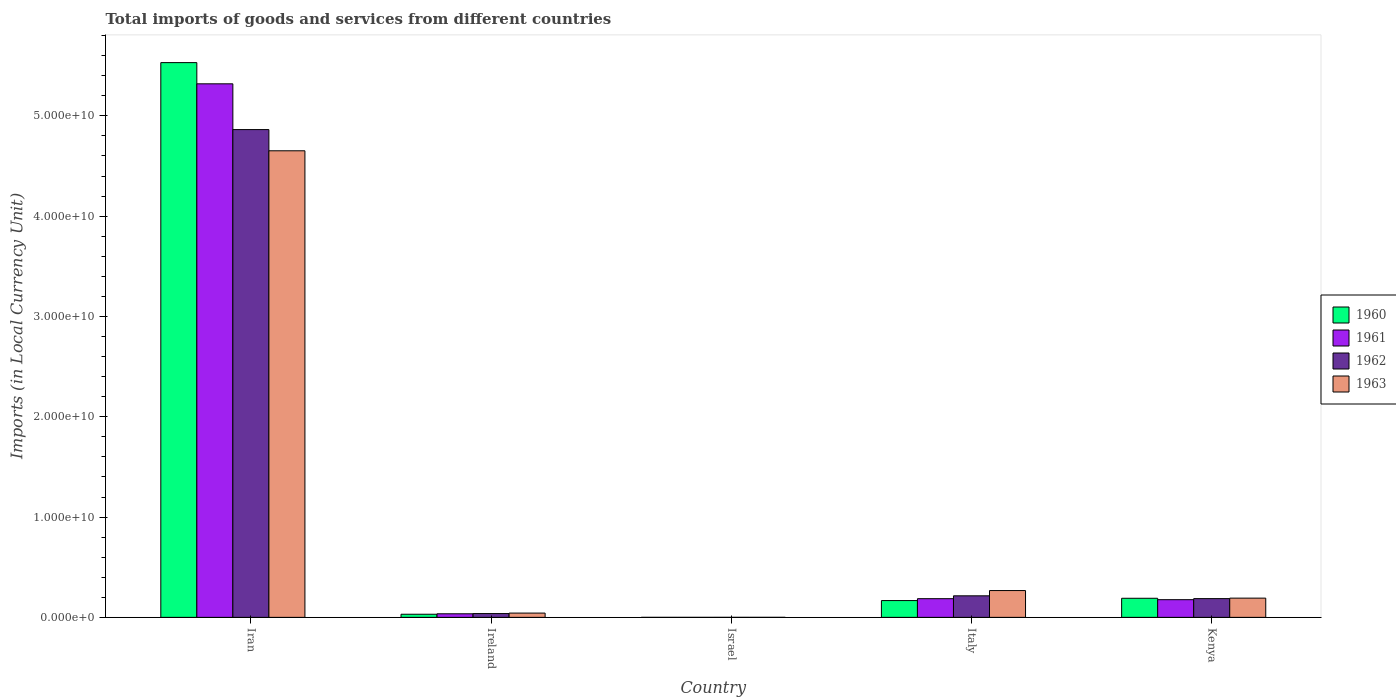What is the label of the 2nd group of bars from the left?
Keep it short and to the point. Ireland. What is the Amount of goods and services imports in 1962 in Iran?
Your answer should be compact. 4.86e+1. Across all countries, what is the maximum Amount of goods and services imports in 1960?
Your answer should be very brief. 5.53e+1. Across all countries, what is the minimum Amount of goods and services imports in 1962?
Offer a very short reply. 1.26e+05. In which country was the Amount of goods and services imports in 1962 maximum?
Provide a succinct answer. Iran. What is the total Amount of goods and services imports in 1961 in the graph?
Your response must be concise. 5.72e+1. What is the difference between the Amount of goods and services imports in 1960 in Ireland and that in Italy?
Your answer should be compact. -1.36e+09. What is the difference between the Amount of goods and services imports in 1961 in Iran and the Amount of goods and services imports in 1960 in Israel?
Keep it short and to the point. 5.32e+1. What is the average Amount of goods and services imports in 1960 per country?
Your answer should be compact. 1.18e+1. What is the difference between the Amount of goods and services imports of/in 1963 and Amount of goods and services imports of/in 1961 in Italy?
Offer a terse response. 8.10e+08. In how many countries, is the Amount of goods and services imports in 1961 greater than 26000000000 LCU?
Make the answer very short. 1. What is the ratio of the Amount of goods and services imports in 1961 in Iran to that in Israel?
Make the answer very short. 7.56e+05. Is the Amount of goods and services imports in 1961 in Ireland less than that in Italy?
Keep it short and to the point. Yes. Is the difference between the Amount of goods and services imports in 1963 in Italy and Kenya greater than the difference between the Amount of goods and services imports in 1961 in Italy and Kenya?
Your answer should be very brief. Yes. What is the difference between the highest and the second highest Amount of goods and services imports in 1960?
Give a very brief answer. -2.29e+08. What is the difference between the highest and the lowest Amount of goods and services imports in 1961?
Your answer should be compact. 5.32e+1. In how many countries, is the Amount of goods and services imports in 1960 greater than the average Amount of goods and services imports in 1960 taken over all countries?
Give a very brief answer. 1. Is it the case that in every country, the sum of the Amount of goods and services imports in 1960 and Amount of goods and services imports in 1962 is greater than the sum of Amount of goods and services imports in 1961 and Amount of goods and services imports in 1963?
Make the answer very short. No. What does the 4th bar from the left in Israel represents?
Offer a very short reply. 1963. Is it the case that in every country, the sum of the Amount of goods and services imports in 1960 and Amount of goods and services imports in 1961 is greater than the Amount of goods and services imports in 1962?
Offer a very short reply. Yes. How many countries are there in the graph?
Your answer should be very brief. 5. What is the difference between two consecutive major ticks on the Y-axis?
Your answer should be very brief. 1.00e+1. Does the graph contain grids?
Keep it short and to the point. No. Where does the legend appear in the graph?
Your answer should be very brief. Center right. How are the legend labels stacked?
Your answer should be very brief. Vertical. What is the title of the graph?
Make the answer very short. Total imports of goods and services from different countries. What is the label or title of the X-axis?
Provide a succinct answer. Country. What is the label or title of the Y-axis?
Offer a terse response. Imports (in Local Currency Unit). What is the Imports (in Local Currency Unit) of 1960 in Iran?
Ensure brevity in your answer.  5.53e+1. What is the Imports (in Local Currency Unit) of 1961 in Iran?
Provide a short and direct response. 5.32e+1. What is the Imports (in Local Currency Unit) in 1962 in Iran?
Your response must be concise. 4.86e+1. What is the Imports (in Local Currency Unit) of 1963 in Iran?
Your answer should be very brief. 4.65e+1. What is the Imports (in Local Currency Unit) of 1960 in Ireland?
Keep it short and to the point. 3.10e+08. What is the Imports (in Local Currency Unit) in 1961 in Ireland?
Offer a terse response. 3.57e+08. What is the Imports (in Local Currency Unit) of 1962 in Ireland?
Offer a terse response. 3.78e+08. What is the Imports (in Local Currency Unit) of 1963 in Ireland?
Give a very brief answer. 4.26e+08. What is the Imports (in Local Currency Unit) in 1960 in Israel?
Offer a very short reply. 5.78e+04. What is the Imports (in Local Currency Unit) of 1961 in Israel?
Provide a short and direct response. 7.04e+04. What is the Imports (in Local Currency Unit) in 1962 in Israel?
Ensure brevity in your answer.  1.26e+05. What is the Imports (in Local Currency Unit) of 1963 in Israel?
Offer a terse response. 1.44e+05. What is the Imports (in Local Currency Unit) in 1960 in Italy?
Make the answer very short. 1.67e+09. What is the Imports (in Local Currency Unit) of 1961 in Italy?
Your answer should be compact. 1.86e+09. What is the Imports (in Local Currency Unit) in 1962 in Italy?
Ensure brevity in your answer.  2.15e+09. What is the Imports (in Local Currency Unit) in 1963 in Italy?
Offer a terse response. 2.67e+09. What is the Imports (in Local Currency Unit) of 1960 in Kenya?
Ensure brevity in your answer.  1.90e+09. What is the Imports (in Local Currency Unit) in 1961 in Kenya?
Ensure brevity in your answer.  1.76e+09. What is the Imports (in Local Currency Unit) in 1962 in Kenya?
Offer a very short reply. 1.87e+09. What is the Imports (in Local Currency Unit) in 1963 in Kenya?
Make the answer very short. 1.92e+09. Across all countries, what is the maximum Imports (in Local Currency Unit) in 1960?
Your response must be concise. 5.53e+1. Across all countries, what is the maximum Imports (in Local Currency Unit) of 1961?
Keep it short and to the point. 5.32e+1. Across all countries, what is the maximum Imports (in Local Currency Unit) in 1962?
Your answer should be compact. 4.86e+1. Across all countries, what is the maximum Imports (in Local Currency Unit) in 1963?
Offer a terse response. 4.65e+1. Across all countries, what is the minimum Imports (in Local Currency Unit) of 1960?
Keep it short and to the point. 5.78e+04. Across all countries, what is the minimum Imports (in Local Currency Unit) of 1961?
Ensure brevity in your answer.  7.04e+04. Across all countries, what is the minimum Imports (in Local Currency Unit) of 1962?
Give a very brief answer. 1.26e+05. Across all countries, what is the minimum Imports (in Local Currency Unit) in 1963?
Provide a succinct answer. 1.44e+05. What is the total Imports (in Local Currency Unit) in 1960 in the graph?
Provide a succinct answer. 5.92e+1. What is the total Imports (in Local Currency Unit) in 1961 in the graph?
Keep it short and to the point. 5.72e+1. What is the total Imports (in Local Currency Unit) in 1962 in the graph?
Your answer should be very brief. 5.30e+1. What is the total Imports (in Local Currency Unit) of 1963 in the graph?
Give a very brief answer. 5.15e+1. What is the difference between the Imports (in Local Currency Unit) of 1960 in Iran and that in Ireland?
Your answer should be compact. 5.50e+1. What is the difference between the Imports (in Local Currency Unit) of 1961 in Iran and that in Ireland?
Offer a terse response. 5.28e+1. What is the difference between the Imports (in Local Currency Unit) in 1962 in Iran and that in Ireland?
Provide a succinct answer. 4.83e+1. What is the difference between the Imports (in Local Currency Unit) of 1963 in Iran and that in Ireland?
Make the answer very short. 4.61e+1. What is the difference between the Imports (in Local Currency Unit) in 1960 in Iran and that in Israel?
Offer a terse response. 5.53e+1. What is the difference between the Imports (in Local Currency Unit) in 1961 in Iran and that in Israel?
Make the answer very short. 5.32e+1. What is the difference between the Imports (in Local Currency Unit) in 1962 in Iran and that in Israel?
Ensure brevity in your answer.  4.86e+1. What is the difference between the Imports (in Local Currency Unit) in 1963 in Iran and that in Israel?
Provide a short and direct response. 4.65e+1. What is the difference between the Imports (in Local Currency Unit) of 1960 in Iran and that in Italy?
Ensure brevity in your answer.  5.36e+1. What is the difference between the Imports (in Local Currency Unit) in 1961 in Iran and that in Italy?
Give a very brief answer. 5.13e+1. What is the difference between the Imports (in Local Currency Unit) of 1962 in Iran and that in Italy?
Offer a very short reply. 4.65e+1. What is the difference between the Imports (in Local Currency Unit) in 1963 in Iran and that in Italy?
Make the answer very short. 4.38e+1. What is the difference between the Imports (in Local Currency Unit) of 1960 in Iran and that in Kenya?
Provide a succinct answer. 5.34e+1. What is the difference between the Imports (in Local Currency Unit) in 1961 in Iran and that in Kenya?
Provide a short and direct response. 5.14e+1. What is the difference between the Imports (in Local Currency Unit) in 1962 in Iran and that in Kenya?
Provide a short and direct response. 4.68e+1. What is the difference between the Imports (in Local Currency Unit) of 1963 in Iran and that in Kenya?
Your answer should be compact. 4.46e+1. What is the difference between the Imports (in Local Currency Unit) in 1960 in Ireland and that in Israel?
Your answer should be compact. 3.10e+08. What is the difference between the Imports (in Local Currency Unit) of 1961 in Ireland and that in Israel?
Give a very brief answer. 3.56e+08. What is the difference between the Imports (in Local Currency Unit) of 1962 in Ireland and that in Israel?
Ensure brevity in your answer.  3.77e+08. What is the difference between the Imports (in Local Currency Unit) of 1963 in Ireland and that in Israel?
Offer a terse response. 4.25e+08. What is the difference between the Imports (in Local Currency Unit) of 1960 in Ireland and that in Italy?
Provide a short and direct response. -1.36e+09. What is the difference between the Imports (in Local Currency Unit) of 1961 in Ireland and that in Italy?
Provide a short and direct response. -1.51e+09. What is the difference between the Imports (in Local Currency Unit) in 1962 in Ireland and that in Italy?
Make the answer very short. -1.77e+09. What is the difference between the Imports (in Local Currency Unit) of 1963 in Ireland and that in Italy?
Give a very brief answer. -2.25e+09. What is the difference between the Imports (in Local Currency Unit) in 1960 in Ireland and that in Kenya?
Your response must be concise. -1.59e+09. What is the difference between the Imports (in Local Currency Unit) of 1961 in Ireland and that in Kenya?
Keep it short and to the point. -1.41e+09. What is the difference between the Imports (in Local Currency Unit) in 1962 in Ireland and that in Kenya?
Provide a short and direct response. -1.49e+09. What is the difference between the Imports (in Local Currency Unit) in 1963 in Ireland and that in Kenya?
Your response must be concise. -1.49e+09. What is the difference between the Imports (in Local Currency Unit) of 1960 in Israel and that in Italy?
Provide a short and direct response. -1.67e+09. What is the difference between the Imports (in Local Currency Unit) in 1961 in Israel and that in Italy?
Your answer should be very brief. -1.86e+09. What is the difference between the Imports (in Local Currency Unit) in 1962 in Israel and that in Italy?
Offer a terse response. -2.15e+09. What is the difference between the Imports (in Local Currency Unit) of 1963 in Israel and that in Italy?
Keep it short and to the point. -2.67e+09. What is the difference between the Imports (in Local Currency Unit) in 1960 in Israel and that in Kenya?
Provide a succinct answer. -1.90e+09. What is the difference between the Imports (in Local Currency Unit) in 1961 in Israel and that in Kenya?
Ensure brevity in your answer.  -1.76e+09. What is the difference between the Imports (in Local Currency Unit) of 1962 in Israel and that in Kenya?
Ensure brevity in your answer.  -1.87e+09. What is the difference between the Imports (in Local Currency Unit) of 1963 in Israel and that in Kenya?
Offer a very short reply. -1.92e+09. What is the difference between the Imports (in Local Currency Unit) in 1960 in Italy and that in Kenya?
Give a very brief answer. -2.29e+08. What is the difference between the Imports (in Local Currency Unit) in 1961 in Italy and that in Kenya?
Keep it short and to the point. 9.87e+07. What is the difference between the Imports (in Local Currency Unit) of 1962 in Italy and that in Kenya?
Offer a very short reply. 2.80e+08. What is the difference between the Imports (in Local Currency Unit) in 1963 in Italy and that in Kenya?
Offer a terse response. 7.55e+08. What is the difference between the Imports (in Local Currency Unit) in 1960 in Iran and the Imports (in Local Currency Unit) in 1961 in Ireland?
Make the answer very short. 5.50e+1. What is the difference between the Imports (in Local Currency Unit) in 1960 in Iran and the Imports (in Local Currency Unit) in 1962 in Ireland?
Your response must be concise. 5.49e+1. What is the difference between the Imports (in Local Currency Unit) in 1960 in Iran and the Imports (in Local Currency Unit) in 1963 in Ireland?
Provide a short and direct response. 5.49e+1. What is the difference between the Imports (in Local Currency Unit) in 1961 in Iran and the Imports (in Local Currency Unit) in 1962 in Ireland?
Provide a short and direct response. 5.28e+1. What is the difference between the Imports (in Local Currency Unit) of 1961 in Iran and the Imports (in Local Currency Unit) of 1963 in Ireland?
Give a very brief answer. 5.28e+1. What is the difference between the Imports (in Local Currency Unit) in 1962 in Iran and the Imports (in Local Currency Unit) in 1963 in Ireland?
Provide a short and direct response. 4.82e+1. What is the difference between the Imports (in Local Currency Unit) of 1960 in Iran and the Imports (in Local Currency Unit) of 1961 in Israel?
Offer a very short reply. 5.53e+1. What is the difference between the Imports (in Local Currency Unit) of 1960 in Iran and the Imports (in Local Currency Unit) of 1962 in Israel?
Offer a very short reply. 5.53e+1. What is the difference between the Imports (in Local Currency Unit) of 1960 in Iran and the Imports (in Local Currency Unit) of 1963 in Israel?
Offer a very short reply. 5.53e+1. What is the difference between the Imports (in Local Currency Unit) of 1961 in Iran and the Imports (in Local Currency Unit) of 1962 in Israel?
Give a very brief answer. 5.32e+1. What is the difference between the Imports (in Local Currency Unit) of 1961 in Iran and the Imports (in Local Currency Unit) of 1963 in Israel?
Ensure brevity in your answer.  5.32e+1. What is the difference between the Imports (in Local Currency Unit) in 1962 in Iran and the Imports (in Local Currency Unit) in 1963 in Israel?
Keep it short and to the point. 4.86e+1. What is the difference between the Imports (in Local Currency Unit) in 1960 in Iran and the Imports (in Local Currency Unit) in 1961 in Italy?
Provide a succinct answer. 5.34e+1. What is the difference between the Imports (in Local Currency Unit) in 1960 in Iran and the Imports (in Local Currency Unit) in 1962 in Italy?
Provide a short and direct response. 5.32e+1. What is the difference between the Imports (in Local Currency Unit) of 1960 in Iran and the Imports (in Local Currency Unit) of 1963 in Italy?
Keep it short and to the point. 5.26e+1. What is the difference between the Imports (in Local Currency Unit) in 1961 in Iran and the Imports (in Local Currency Unit) in 1962 in Italy?
Offer a terse response. 5.10e+1. What is the difference between the Imports (in Local Currency Unit) of 1961 in Iran and the Imports (in Local Currency Unit) of 1963 in Italy?
Give a very brief answer. 5.05e+1. What is the difference between the Imports (in Local Currency Unit) of 1962 in Iran and the Imports (in Local Currency Unit) of 1963 in Italy?
Give a very brief answer. 4.60e+1. What is the difference between the Imports (in Local Currency Unit) of 1960 in Iran and the Imports (in Local Currency Unit) of 1961 in Kenya?
Offer a terse response. 5.35e+1. What is the difference between the Imports (in Local Currency Unit) of 1960 in Iran and the Imports (in Local Currency Unit) of 1962 in Kenya?
Your response must be concise. 5.34e+1. What is the difference between the Imports (in Local Currency Unit) of 1960 in Iran and the Imports (in Local Currency Unit) of 1963 in Kenya?
Your answer should be very brief. 5.34e+1. What is the difference between the Imports (in Local Currency Unit) of 1961 in Iran and the Imports (in Local Currency Unit) of 1962 in Kenya?
Give a very brief answer. 5.13e+1. What is the difference between the Imports (in Local Currency Unit) in 1961 in Iran and the Imports (in Local Currency Unit) in 1963 in Kenya?
Your answer should be compact. 5.13e+1. What is the difference between the Imports (in Local Currency Unit) in 1962 in Iran and the Imports (in Local Currency Unit) in 1963 in Kenya?
Keep it short and to the point. 4.67e+1. What is the difference between the Imports (in Local Currency Unit) of 1960 in Ireland and the Imports (in Local Currency Unit) of 1961 in Israel?
Make the answer very short. 3.10e+08. What is the difference between the Imports (in Local Currency Unit) in 1960 in Ireland and the Imports (in Local Currency Unit) in 1962 in Israel?
Your response must be concise. 3.10e+08. What is the difference between the Imports (in Local Currency Unit) in 1960 in Ireland and the Imports (in Local Currency Unit) in 1963 in Israel?
Give a very brief answer. 3.10e+08. What is the difference between the Imports (in Local Currency Unit) in 1961 in Ireland and the Imports (in Local Currency Unit) in 1962 in Israel?
Your answer should be very brief. 3.56e+08. What is the difference between the Imports (in Local Currency Unit) of 1961 in Ireland and the Imports (in Local Currency Unit) of 1963 in Israel?
Provide a short and direct response. 3.56e+08. What is the difference between the Imports (in Local Currency Unit) in 1962 in Ireland and the Imports (in Local Currency Unit) in 1963 in Israel?
Give a very brief answer. 3.77e+08. What is the difference between the Imports (in Local Currency Unit) of 1960 in Ireland and the Imports (in Local Currency Unit) of 1961 in Italy?
Your answer should be compact. -1.55e+09. What is the difference between the Imports (in Local Currency Unit) in 1960 in Ireland and the Imports (in Local Currency Unit) in 1962 in Italy?
Offer a terse response. -1.84e+09. What is the difference between the Imports (in Local Currency Unit) in 1960 in Ireland and the Imports (in Local Currency Unit) in 1963 in Italy?
Provide a short and direct response. -2.36e+09. What is the difference between the Imports (in Local Currency Unit) in 1961 in Ireland and the Imports (in Local Currency Unit) in 1962 in Italy?
Your answer should be very brief. -1.79e+09. What is the difference between the Imports (in Local Currency Unit) of 1961 in Ireland and the Imports (in Local Currency Unit) of 1963 in Italy?
Offer a very short reply. -2.32e+09. What is the difference between the Imports (in Local Currency Unit) of 1962 in Ireland and the Imports (in Local Currency Unit) of 1963 in Italy?
Provide a short and direct response. -2.29e+09. What is the difference between the Imports (in Local Currency Unit) in 1960 in Ireland and the Imports (in Local Currency Unit) in 1961 in Kenya?
Offer a very short reply. -1.45e+09. What is the difference between the Imports (in Local Currency Unit) of 1960 in Ireland and the Imports (in Local Currency Unit) of 1962 in Kenya?
Your answer should be very brief. -1.56e+09. What is the difference between the Imports (in Local Currency Unit) of 1960 in Ireland and the Imports (in Local Currency Unit) of 1963 in Kenya?
Offer a terse response. -1.61e+09. What is the difference between the Imports (in Local Currency Unit) of 1961 in Ireland and the Imports (in Local Currency Unit) of 1962 in Kenya?
Offer a terse response. -1.51e+09. What is the difference between the Imports (in Local Currency Unit) in 1961 in Ireland and the Imports (in Local Currency Unit) in 1963 in Kenya?
Keep it short and to the point. -1.56e+09. What is the difference between the Imports (in Local Currency Unit) of 1962 in Ireland and the Imports (in Local Currency Unit) of 1963 in Kenya?
Make the answer very short. -1.54e+09. What is the difference between the Imports (in Local Currency Unit) in 1960 in Israel and the Imports (in Local Currency Unit) in 1961 in Italy?
Provide a short and direct response. -1.86e+09. What is the difference between the Imports (in Local Currency Unit) of 1960 in Israel and the Imports (in Local Currency Unit) of 1962 in Italy?
Your answer should be compact. -2.15e+09. What is the difference between the Imports (in Local Currency Unit) in 1960 in Israel and the Imports (in Local Currency Unit) in 1963 in Italy?
Offer a very short reply. -2.67e+09. What is the difference between the Imports (in Local Currency Unit) of 1961 in Israel and the Imports (in Local Currency Unit) of 1962 in Italy?
Offer a very short reply. -2.15e+09. What is the difference between the Imports (in Local Currency Unit) in 1961 in Israel and the Imports (in Local Currency Unit) in 1963 in Italy?
Your answer should be compact. -2.67e+09. What is the difference between the Imports (in Local Currency Unit) in 1962 in Israel and the Imports (in Local Currency Unit) in 1963 in Italy?
Your answer should be very brief. -2.67e+09. What is the difference between the Imports (in Local Currency Unit) of 1960 in Israel and the Imports (in Local Currency Unit) of 1961 in Kenya?
Keep it short and to the point. -1.76e+09. What is the difference between the Imports (in Local Currency Unit) of 1960 in Israel and the Imports (in Local Currency Unit) of 1962 in Kenya?
Keep it short and to the point. -1.87e+09. What is the difference between the Imports (in Local Currency Unit) of 1960 in Israel and the Imports (in Local Currency Unit) of 1963 in Kenya?
Offer a terse response. -1.92e+09. What is the difference between the Imports (in Local Currency Unit) in 1961 in Israel and the Imports (in Local Currency Unit) in 1962 in Kenya?
Keep it short and to the point. -1.87e+09. What is the difference between the Imports (in Local Currency Unit) in 1961 in Israel and the Imports (in Local Currency Unit) in 1963 in Kenya?
Keep it short and to the point. -1.92e+09. What is the difference between the Imports (in Local Currency Unit) of 1962 in Israel and the Imports (in Local Currency Unit) of 1963 in Kenya?
Offer a very short reply. -1.92e+09. What is the difference between the Imports (in Local Currency Unit) of 1960 in Italy and the Imports (in Local Currency Unit) of 1961 in Kenya?
Offer a very short reply. -8.91e+07. What is the difference between the Imports (in Local Currency Unit) in 1960 in Italy and the Imports (in Local Currency Unit) in 1962 in Kenya?
Make the answer very short. -1.94e+08. What is the difference between the Imports (in Local Currency Unit) of 1960 in Italy and the Imports (in Local Currency Unit) of 1963 in Kenya?
Make the answer very short. -2.43e+08. What is the difference between the Imports (in Local Currency Unit) of 1961 in Italy and the Imports (in Local Currency Unit) of 1962 in Kenya?
Give a very brief answer. -6.13e+06. What is the difference between the Imports (in Local Currency Unit) in 1961 in Italy and the Imports (in Local Currency Unit) in 1963 in Kenya?
Provide a short and direct response. -5.50e+07. What is the difference between the Imports (in Local Currency Unit) of 1962 in Italy and the Imports (in Local Currency Unit) of 1963 in Kenya?
Your answer should be compact. 2.31e+08. What is the average Imports (in Local Currency Unit) in 1960 per country?
Keep it short and to the point. 1.18e+1. What is the average Imports (in Local Currency Unit) of 1961 per country?
Your response must be concise. 1.14e+1. What is the average Imports (in Local Currency Unit) of 1962 per country?
Your response must be concise. 1.06e+1. What is the average Imports (in Local Currency Unit) of 1963 per country?
Offer a very short reply. 1.03e+1. What is the difference between the Imports (in Local Currency Unit) of 1960 and Imports (in Local Currency Unit) of 1961 in Iran?
Make the answer very short. 2.11e+09. What is the difference between the Imports (in Local Currency Unit) in 1960 and Imports (in Local Currency Unit) in 1962 in Iran?
Make the answer very short. 6.68e+09. What is the difference between the Imports (in Local Currency Unit) of 1960 and Imports (in Local Currency Unit) of 1963 in Iran?
Give a very brief answer. 8.79e+09. What is the difference between the Imports (in Local Currency Unit) in 1961 and Imports (in Local Currency Unit) in 1962 in Iran?
Ensure brevity in your answer.  4.56e+09. What is the difference between the Imports (in Local Currency Unit) of 1961 and Imports (in Local Currency Unit) of 1963 in Iran?
Ensure brevity in your answer.  6.68e+09. What is the difference between the Imports (in Local Currency Unit) in 1962 and Imports (in Local Currency Unit) in 1963 in Iran?
Give a very brief answer. 2.11e+09. What is the difference between the Imports (in Local Currency Unit) in 1960 and Imports (in Local Currency Unit) in 1961 in Ireland?
Your response must be concise. -4.63e+07. What is the difference between the Imports (in Local Currency Unit) in 1960 and Imports (in Local Currency Unit) in 1962 in Ireland?
Make the answer very short. -6.74e+07. What is the difference between the Imports (in Local Currency Unit) of 1960 and Imports (in Local Currency Unit) of 1963 in Ireland?
Your answer should be very brief. -1.15e+08. What is the difference between the Imports (in Local Currency Unit) in 1961 and Imports (in Local Currency Unit) in 1962 in Ireland?
Offer a terse response. -2.11e+07. What is the difference between the Imports (in Local Currency Unit) of 1961 and Imports (in Local Currency Unit) of 1963 in Ireland?
Your answer should be compact. -6.91e+07. What is the difference between the Imports (in Local Currency Unit) of 1962 and Imports (in Local Currency Unit) of 1963 in Ireland?
Your answer should be very brief. -4.80e+07. What is the difference between the Imports (in Local Currency Unit) in 1960 and Imports (in Local Currency Unit) in 1961 in Israel?
Provide a short and direct response. -1.26e+04. What is the difference between the Imports (in Local Currency Unit) of 1960 and Imports (in Local Currency Unit) of 1962 in Israel?
Offer a terse response. -6.82e+04. What is the difference between the Imports (in Local Currency Unit) of 1960 and Imports (in Local Currency Unit) of 1963 in Israel?
Offer a terse response. -8.59e+04. What is the difference between the Imports (in Local Currency Unit) in 1961 and Imports (in Local Currency Unit) in 1962 in Israel?
Offer a terse response. -5.56e+04. What is the difference between the Imports (in Local Currency Unit) of 1961 and Imports (in Local Currency Unit) of 1963 in Israel?
Your answer should be compact. -7.33e+04. What is the difference between the Imports (in Local Currency Unit) of 1962 and Imports (in Local Currency Unit) of 1963 in Israel?
Your answer should be very brief. -1.77e+04. What is the difference between the Imports (in Local Currency Unit) of 1960 and Imports (in Local Currency Unit) of 1961 in Italy?
Offer a very short reply. -1.88e+08. What is the difference between the Imports (in Local Currency Unit) in 1960 and Imports (in Local Currency Unit) in 1962 in Italy?
Your answer should be compact. -4.73e+08. What is the difference between the Imports (in Local Currency Unit) in 1960 and Imports (in Local Currency Unit) in 1963 in Italy?
Offer a very short reply. -9.98e+08. What is the difference between the Imports (in Local Currency Unit) of 1961 and Imports (in Local Currency Unit) of 1962 in Italy?
Offer a very short reply. -2.86e+08. What is the difference between the Imports (in Local Currency Unit) in 1961 and Imports (in Local Currency Unit) in 1963 in Italy?
Keep it short and to the point. -8.10e+08. What is the difference between the Imports (in Local Currency Unit) of 1962 and Imports (in Local Currency Unit) of 1963 in Italy?
Make the answer very short. -5.24e+08. What is the difference between the Imports (in Local Currency Unit) of 1960 and Imports (in Local Currency Unit) of 1961 in Kenya?
Make the answer very short. 1.40e+08. What is the difference between the Imports (in Local Currency Unit) of 1960 and Imports (in Local Currency Unit) of 1962 in Kenya?
Your response must be concise. 3.50e+07. What is the difference between the Imports (in Local Currency Unit) in 1960 and Imports (in Local Currency Unit) in 1963 in Kenya?
Your answer should be compact. -1.39e+07. What is the difference between the Imports (in Local Currency Unit) in 1961 and Imports (in Local Currency Unit) in 1962 in Kenya?
Provide a short and direct response. -1.05e+08. What is the difference between the Imports (in Local Currency Unit) in 1961 and Imports (in Local Currency Unit) in 1963 in Kenya?
Offer a terse response. -1.54e+08. What is the difference between the Imports (in Local Currency Unit) of 1962 and Imports (in Local Currency Unit) of 1963 in Kenya?
Offer a very short reply. -4.89e+07. What is the ratio of the Imports (in Local Currency Unit) of 1960 in Iran to that in Ireland?
Provide a succinct answer. 178.3. What is the ratio of the Imports (in Local Currency Unit) of 1961 in Iran to that in Ireland?
Your answer should be compact. 149.21. What is the ratio of the Imports (in Local Currency Unit) in 1962 in Iran to that in Ireland?
Ensure brevity in your answer.  128.79. What is the ratio of the Imports (in Local Currency Unit) in 1963 in Iran to that in Ireland?
Ensure brevity in your answer.  109.3. What is the ratio of the Imports (in Local Currency Unit) of 1960 in Iran to that in Israel?
Make the answer very short. 9.57e+05. What is the ratio of the Imports (in Local Currency Unit) of 1961 in Iran to that in Israel?
Keep it short and to the point. 7.56e+05. What is the ratio of the Imports (in Local Currency Unit) of 1962 in Iran to that in Israel?
Provide a short and direct response. 3.86e+05. What is the ratio of the Imports (in Local Currency Unit) in 1963 in Iran to that in Israel?
Make the answer very short. 3.24e+05. What is the ratio of the Imports (in Local Currency Unit) in 1960 in Iran to that in Italy?
Give a very brief answer. 33.04. What is the ratio of the Imports (in Local Currency Unit) in 1961 in Iran to that in Italy?
Your answer should be compact. 28.57. What is the ratio of the Imports (in Local Currency Unit) of 1962 in Iran to that in Italy?
Your answer should be very brief. 22.65. What is the ratio of the Imports (in Local Currency Unit) of 1963 in Iran to that in Italy?
Offer a very short reply. 17.41. What is the ratio of the Imports (in Local Currency Unit) of 1960 in Iran to that in Kenya?
Your response must be concise. 29.06. What is the ratio of the Imports (in Local Currency Unit) in 1961 in Iran to that in Kenya?
Offer a very short reply. 30.17. What is the ratio of the Imports (in Local Currency Unit) in 1962 in Iran to that in Kenya?
Give a very brief answer. 26.03. What is the ratio of the Imports (in Local Currency Unit) in 1963 in Iran to that in Kenya?
Keep it short and to the point. 24.27. What is the ratio of the Imports (in Local Currency Unit) in 1960 in Ireland to that in Israel?
Offer a terse response. 5366.95. What is the ratio of the Imports (in Local Currency Unit) in 1961 in Ireland to that in Israel?
Ensure brevity in your answer.  5063.97. What is the ratio of the Imports (in Local Currency Unit) of 1962 in Ireland to that in Israel?
Provide a short and direct response. 2996.88. What is the ratio of the Imports (in Local Currency Unit) in 1963 in Ireland to that in Israel?
Offer a terse response. 2961.83. What is the ratio of the Imports (in Local Currency Unit) in 1960 in Ireland to that in Italy?
Offer a terse response. 0.19. What is the ratio of the Imports (in Local Currency Unit) of 1961 in Ireland to that in Italy?
Your answer should be very brief. 0.19. What is the ratio of the Imports (in Local Currency Unit) in 1962 in Ireland to that in Italy?
Your answer should be compact. 0.18. What is the ratio of the Imports (in Local Currency Unit) of 1963 in Ireland to that in Italy?
Provide a succinct answer. 0.16. What is the ratio of the Imports (in Local Currency Unit) in 1960 in Ireland to that in Kenya?
Your answer should be very brief. 0.16. What is the ratio of the Imports (in Local Currency Unit) of 1961 in Ireland to that in Kenya?
Provide a short and direct response. 0.2. What is the ratio of the Imports (in Local Currency Unit) of 1962 in Ireland to that in Kenya?
Your response must be concise. 0.2. What is the ratio of the Imports (in Local Currency Unit) in 1963 in Ireland to that in Kenya?
Offer a very short reply. 0.22. What is the ratio of the Imports (in Local Currency Unit) of 1961 in Israel to that in Italy?
Provide a succinct answer. 0. What is the ratio of the Imports (in Local Currency Unit) of 1963 in Israel to that in Italy?
Keep it short and to the point. 0. What is the ratio of the Imports (in Local Currency Unit) in 1960 in Israel to that in Kenya?
Ensure brevity in your answer.  0. What is the ratio of the Imports (in Local Currency Unit) of 1961 in Israel to that in Kenya?
Keep it short and to the point. 0. What is the ratio of the Imports (in Local Currency Unit) in 1962 in Israel to that in Kenya?
Offer a terse response. 0. What is the ratio of the Imports (in Local Currency Unit) in 1963 in Israel to that in Kenya?
Offer a very short reply. 0. What is the ratio of the Imports (in Local Currency Unit) in 1960 in Italy to that in Kenya?
Ensure brevity in your answer.  0.88. What is the ratio of the Imports (in Local Currency Unit) of 1961 in Italy to that in Kenya?
Your response must be concise. 1.06. What is the ratio of the Imports (in Local Currency Unit) in 1962 in Italy to that in Kenya?
Provide a short and direct response. 1.15. What is the ratio of the Imports (in Local Currency Unit) of 1963 in Italy to that in Kenya?
Keep it short and to the point. 1.39. What is the difference between the highest and the second highest Imports (in Local Currency Unit) in 1960?
Give a very brief answer. 5.34e+1. What is the difference between the highest and the second highest Imports (in Local Currency Unit) of 1961?
Provide a short and direct response. 5.13e+1. What is the difference between the highest and the second highest Imports (in Local Currency Unit) in 1962?
Ensure brevity in your answer.  4.65e+1. What is the difference between the highest and the second highest Imports (in Local Currency Unit) in 1963?
Offer a terse response. 4.38e+1. What is the difference between the highest and the lowest Imports (in Local Currency Unit) of 1960?
Keep it short and to the point. 5.53e+1. What is the difference between the highest and the lowest Imports (in Local Currency Unit) in 1961?
Your answer should be very brief. 5.32e+1. What is the difference between the highest and the lowest Imports (in Local Currency Unit) in 1962?
Give a very brief answer. 4.86e+1. What is the difference between the highest and the lowest Imports (in Local Currency Unit) of 1963?
Offer a terse response. 4.65e+1. 